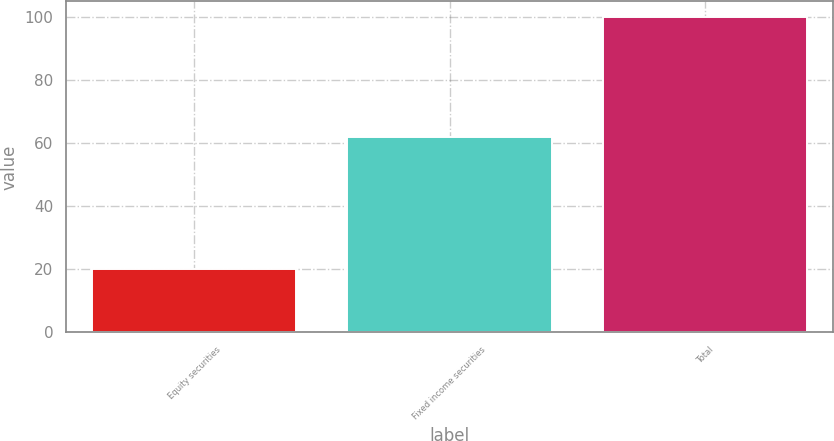Convert chart. <chart><loc_0><loc_0><loc_500><loc_500><bar_chart><fcel>Equity securities<fcel>Fixed income securities<fcel>Total<nl><fcel>20<fcel>62<fcel>100<nl></chart> 